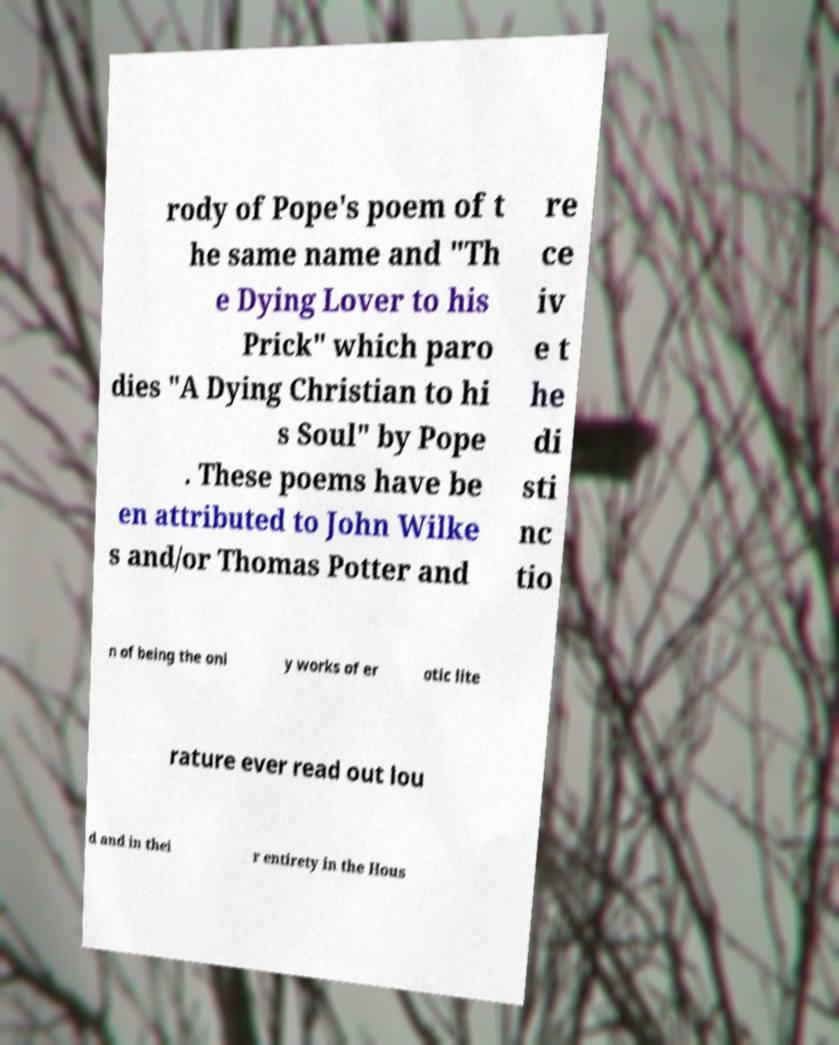Can you read and provide the text displayed in the image?This photo seems to have some interesting text. Can you extract and type it out for me? rody of Pope's poem of t he same name and "Th e Dying Lover to his Prick" which paro dies "A Dying Christian to hi s Soul" by Pope . These poems have be en attributed to John Wilke s and/or Thomas Potter and re ce iv e t he di sti nc tio n of being the onl y works of er otic lite rature ever read out lou d and in thei r entirety in the Hous 